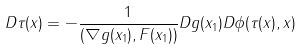Convert formula to latex. <formula><loc_0><loc_0><loc_500><loc_500>D \tau ( x ) = - \frac { 1 } { ( \nabla g ( x _ { 1 } ) , F ( x _ { 1 } ) ) } D g ( x _ { 1 } ) D \phi ( \tau ( x ) , x )</formula> 